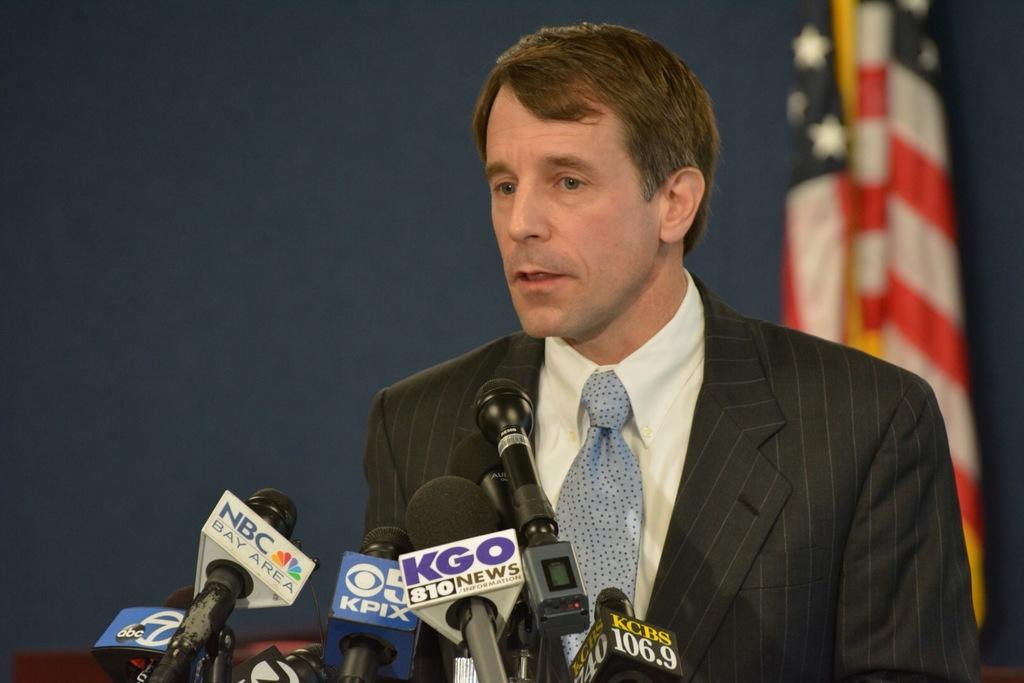What is the man in the image doing? The man is standing and talking in the image. What objects are present on the podium in the foreground? Microphones are present on a podium in the foreground. What can be seen in the background of the image? There is a flag in the background of the image. What is the color of the background in the image? The background of the image is dark blue. Can you tell me how many potatoes are on the podium in the image? There are no potatoes present on the podium or in the image. 